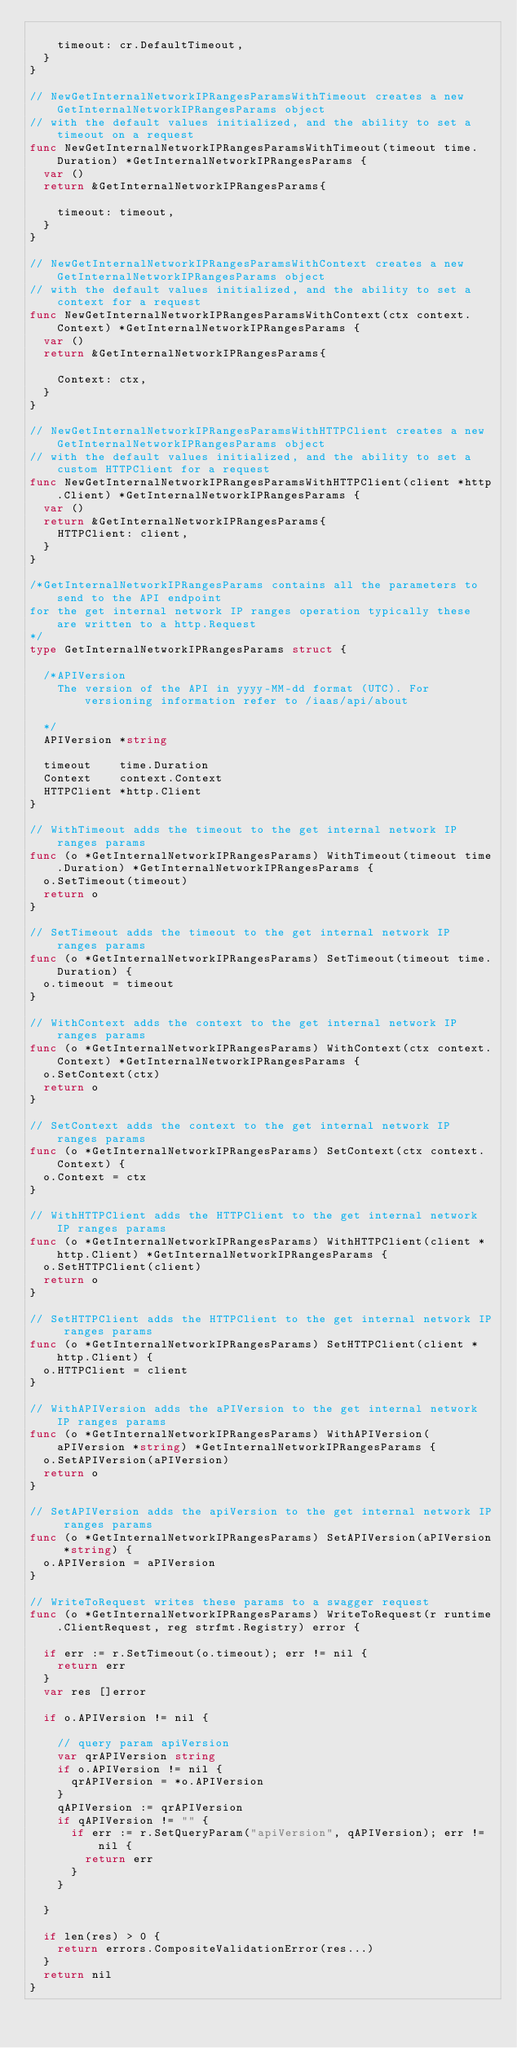Convert code to text. <code><loc_0><loc_0><loc_500><loc_500><_Go_>
		timeout: cr.DefaultTimeout,
	}
}

// NewGetInternalNetworkIPRangesParamsWithTimeout creates a new GetInternalNetworkIPRangesParams object
// with the default values initialized, and the ability to set a timeout on a request
func NewGetInternalNetworkIPRangesParamsWithTimeout(timeout time.Duration) *GetInternalNetworkIPRangesParams {
	var ()
	return &GetInternalNetworkIPRangesParams{

		timeout: timeout,
	}
}

// NewGetInternalNetworkIPRangesParamsWithContext creates a new GetInternalNetworkIPRangesParams object
// with the default values initialized, and the ability to set a context for a request
func NewGetInternalNetworkIPRangesParamsWithContext(ctx context.Context) *GetInternalNetworkIPRangesParams {
	var ()
	return &GetInternalNetworkIPRangesParams{

		Context: ctx,
	}
}

// NewGetInternalNetworkIPRangesParamsWithHTTPClient creates a new GetInternalNetworkIPRangesParams object
// with the default values initialized, and the ability to set a custom HTTPClient for a request
func NewGetInternalNetworkIPRangesParamsWithHTTPClient(client *http.Client) *GetInternalNetworkIPRangesParams {
	var ()
	return &GetInternalNetworkIPRangesParams{
		HTTPClient: client,
	}
}

/*GetInternalNetworkIPRangesParams contains all the parameters to send to the API endpoint
for the get internal network IP ranges operation typically these are written to a http.Request
*/
type GetInternalNetworkIPRangesParams struct {

	/*APIVersion
	  The version of the API in yyyy-MM-dd format (UTC). For versioning information refer to /iaas/api/about

	*/
	APIVersion *string

	timeout    time.Duration
	Context    context.Context
	HTTPClient *http.Client
}

// WithTimeout adds the timeout to the get internal network IP ranges params
func (o *GetInternalNetworkIPRangesParams) WithTimeout(timeout time.Duration) *GetInternalNetworkIPRangesParams {
	o.SetTimeout(timeout)
	return o
}

// SetTimeout adds the timeout to the get internal network IP ranges params
func (o *GetInternalNetworkIPRangesParams) SetTimeout(timeout time.Duration) {
	o.timeout = timeout
}

// WithContext adds the context to the get internal network IP ranges params
func (o *GetInternalNetworkIPRangesParams) WithContext(ctx context.Context) *GetInternalNetworkIPRangesParams {
	o.SetContext(ctx)
	return o
}

// SetContext adds the context to the get internal network IP ranges params
func (o *GetInternalNetworkIPRangesParams) SetContext(ctx context.Context) {
	o.Context = ctx
}

// WithHTTPClient adds the HTTPClient to the get internal network IP ranges params
func (o *GetInternalNetworkIPRangesParams) WithHTTPClient(client *http.Client) *GetInternalNetworkIPRangesParams {
	o.SetHTTPClient(client)
	return o
}

// SetHTTPClient adds the HTTPClient to the get internal network IP ranges params
func (o *GetInternalNetworkIPRangesParams) SetHTTPClient(client *http.Client) {
	o.HTTPClient = client
}

// WithAPIVersion adds the aPIVersion to the get internal network IP ranges params
func (o *GetInternalNetworkIPRangesParams) WithAPIVersion(aPIVersion *string) *GetInternalNetworkIPRangesParams {
	o.SetAPIVersion(aPIVersion)
	return o
}

// SetAPIVersion adds the apiVersion to the get internal network IP ranges params
func (o *GetInternalNetworkIPRangesParams) SetAPIVersion(aPIVersion *string) {
	o.APIVersion = aPIVersion
}

// WriteToRequest writes these params to a swagger request
func (o *GetInternalNetworkIPRangesParams) WriteToRequest(r runtime.ClientRequest, reg strfmt.Registry) error {

	if err := r.SetTimeout(o.timeout); err != nil {
		return err
	}
	var res []error

	if o.APIVersion != nil {

		// query param apiVersion
		var qrAPIVersion string
		if o.APIVersion != nil {
			qrAPIVersion = *o.APIVersion
		}
		qAPIVersion := qrAPIVersion
		if qAPIVersion != "" {
			if err := r.SetQueryParam("apiVersion", qAPIVersion); err != nil {
				return err
			}
		}

	}

	if len(res) > 0 {
		return errors.CompositeValidationError(res...)
	}
	return nil
}
</code> 